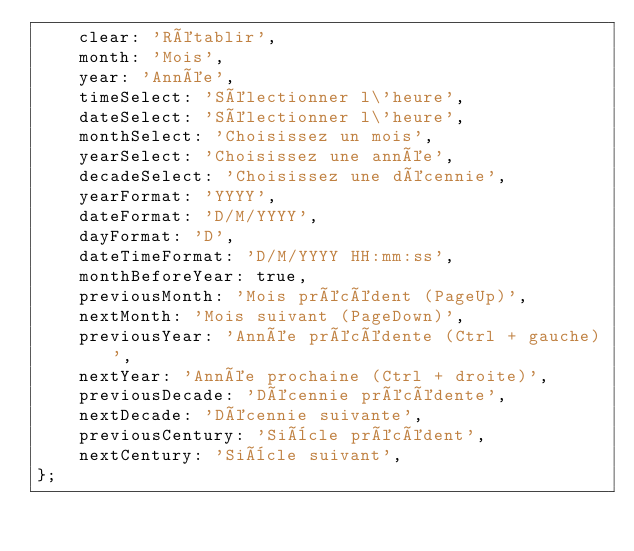Convert code to text. <code><loc_0><loc_0><loc_500><loc_500><_JavaScript_>    clear: 'Rétablir',
    month: 'Mois',
    year: 'Année',
    timeSelect: 'Sélectionner l\'heure',
    dateSelect: 'Sélectionner l\'heure',
    monthSelect: 'Choisissez un mois',
    yearSelect: 'Choisissez une année',
    decadeSelect: 'Choisissez une décennie',
    yearFormat: 'YYYY',
    dateFormat: 'D/M/YYYY',
    dayFormat: 'D',
    dateTimeFormat: 'D/M/YYYY HH:mm:ss',
    monthBeforeYear: true,
    previousMonth: 'Mois précédent (PageUp)',
    nextMonth: 'Mois suivant (PageDown)',
    previousYear: 'Année précédente (Ctrl + gauche)',
    nextYear: 'Année prochaine (Ctrl + droite)',
    previousDecade: 'Décennie précédente',
    nextDecade: 'Décennie suivante',
    previousCentury: 'Siècle précédent',
    nextCentury: 'Siècle suivant',
};
</code> 